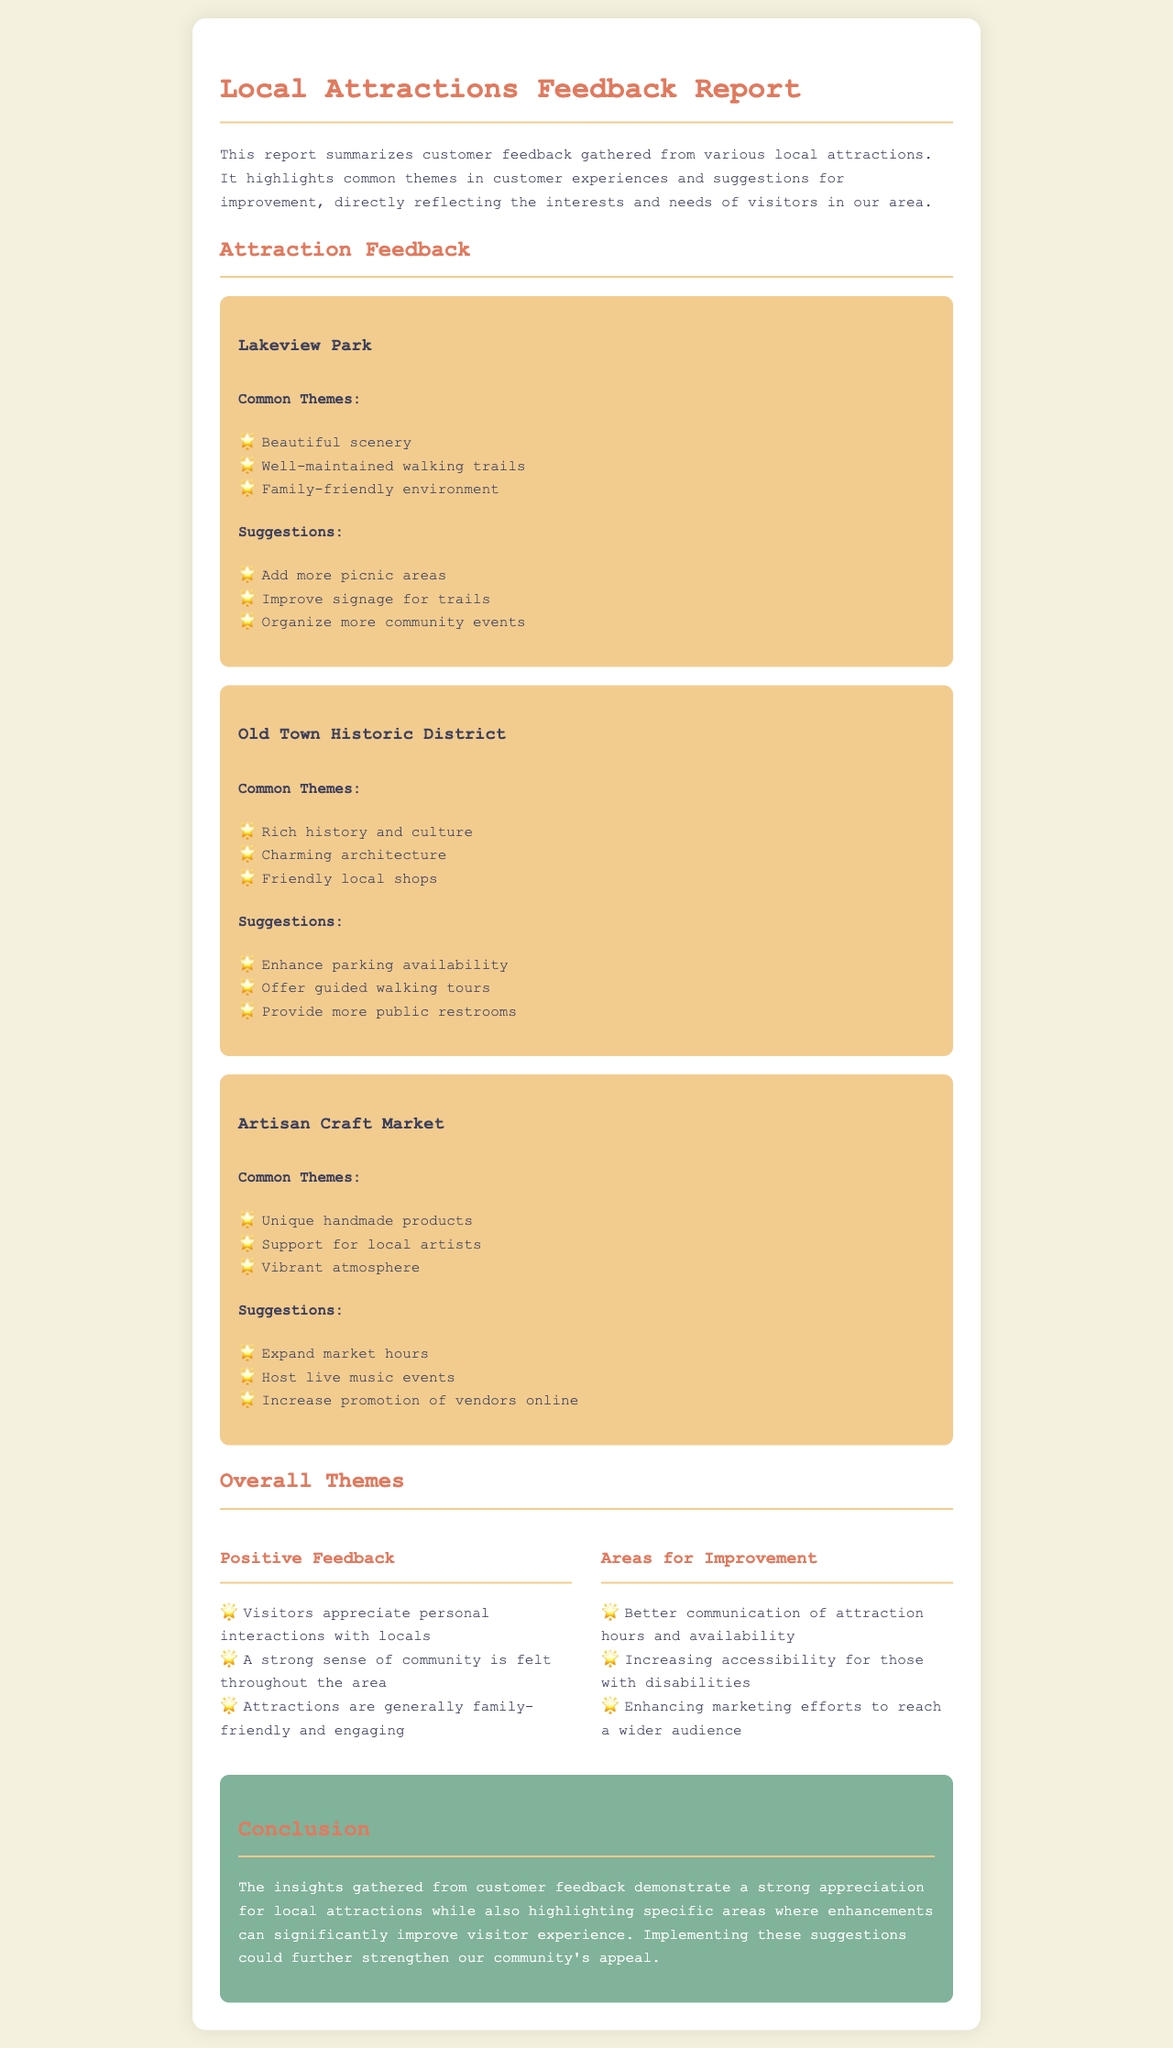What are the common themes for Lakeview Park? The common themes are listed under Lakeview Park, which include beautiful scenery, well-maintained walking trails, and family-friendly environment.
Answer: Beautiful scenery, well-maintained walking trails, family-friendly environment What suggestions were made for the Old Town Historic District? The suggestions for Old Town Historic District are provided and include enhancing parking availability, offering guided walking tours, and providing more public restrooms.
Answer: Enhance parking availability, offer guided walking tours, provide more public restrooms What is one area for improvement mentioned in the overall themes? The areas for improvement are listed, and one of them is better communication of attraction hours and availability.
Answer: Better communication of attraction hours and availability How is the Artisan Craft Market characterized by visitors? Visitors characterize the Artisan Craft Market with common themes that include unique handmade products, support for local artists, and a vibrant atmosphere.
Answer: Unique handmade products, support for local artists, vibrant atmosphere What does the conclusion emphasize about customer feedback? The conclusion summarizes the document by highlighting a strong appreciation for local attractions and specific areas where enhancements can be made.
Answer: Strong appreciation for local attractions What is a positive feedback theme identified in the overall themes section? The positive feedback theme includes that visitors appreciate personal interactions with locals.
Answer: Visitors appreciate personal interactions with locals What are some common suggestions for Lakeview Park? Suggestions for Lakeview Park include adding more picnic areas, improving signage for trails, and organizing more community events.
Answer: Add more picnic areas, improve signage for trails, organize more community events 